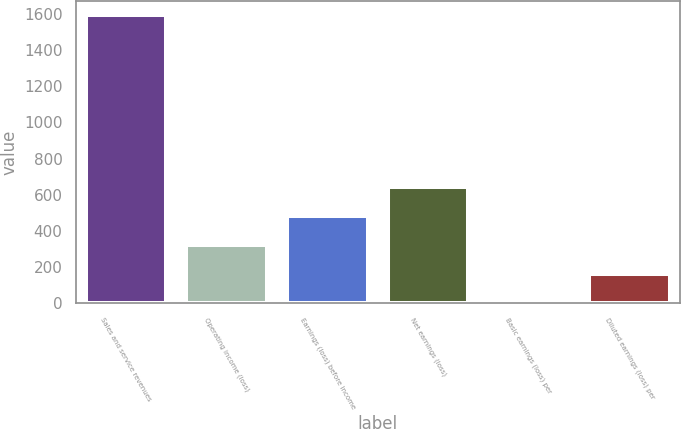Convert chart to OTSL. <chart><loc_0><loc_0><loc_500><loc_500><bar_chart><fcel>Sales and service revenues<fcel>Operating income (loss)<fcel>Earnings (loss) before income<fcel>Net earnings (loss)<fcel>Basic earnings (loss) per<fcel>Diluted earnings (loss) per<nl><fcel>1593<fcel>322.69<fcel>481.48<fcel>640.27<fcel>5.11<fcel>163.9<nl></chart> 